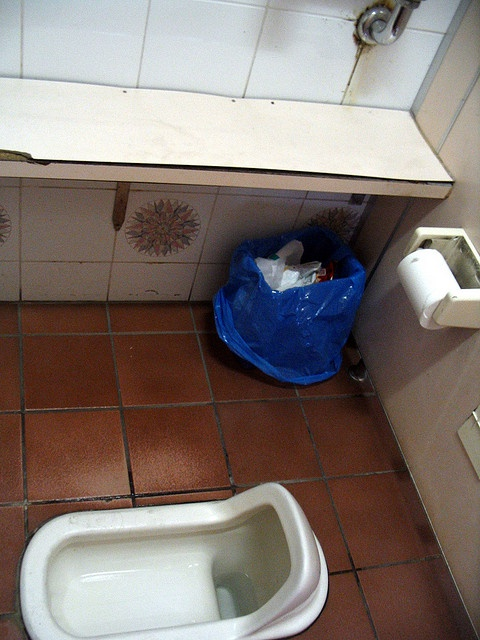Describe the objects in this image and their specific colors. I can see a toilet in darkgray, lightgray, and gray tones in this image. 